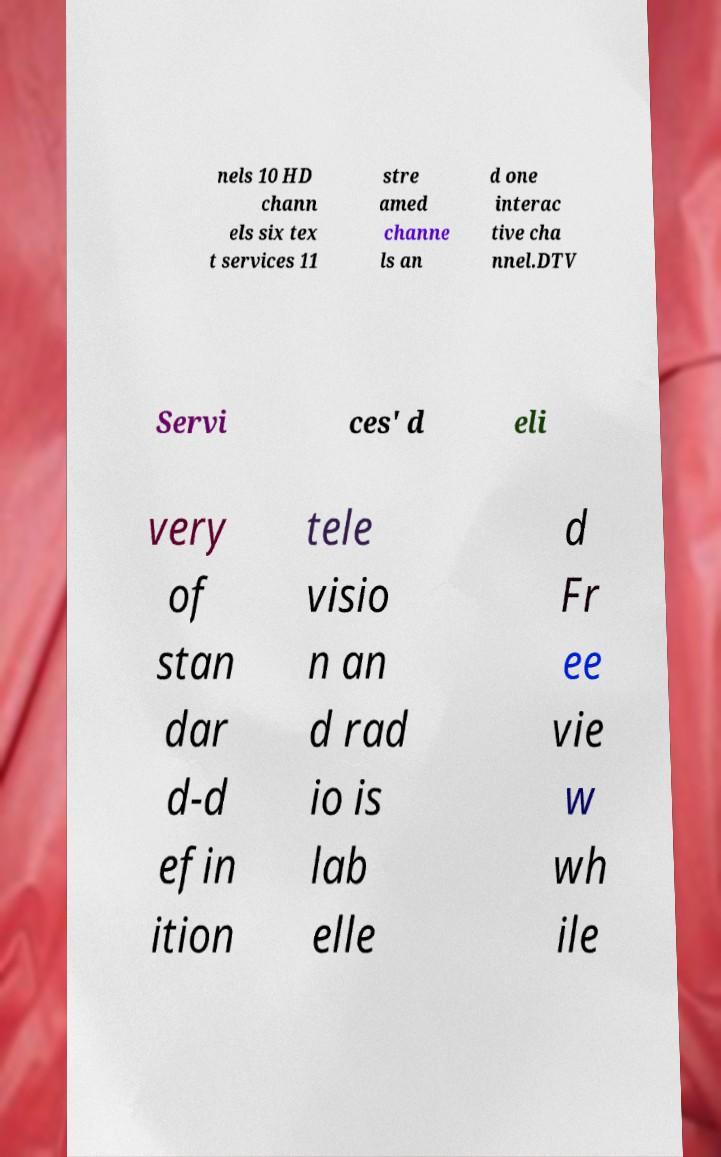Could you extract and type out the text from this image? nels 10 HD chann els six tex t services 11 stre amed channe ls an d one interac tive cha nnel.DTV Servi ces' d eli very of stan dar d-d efin ition tele visio n an d rad io is lab elle d Fr ee vie w wh ile 